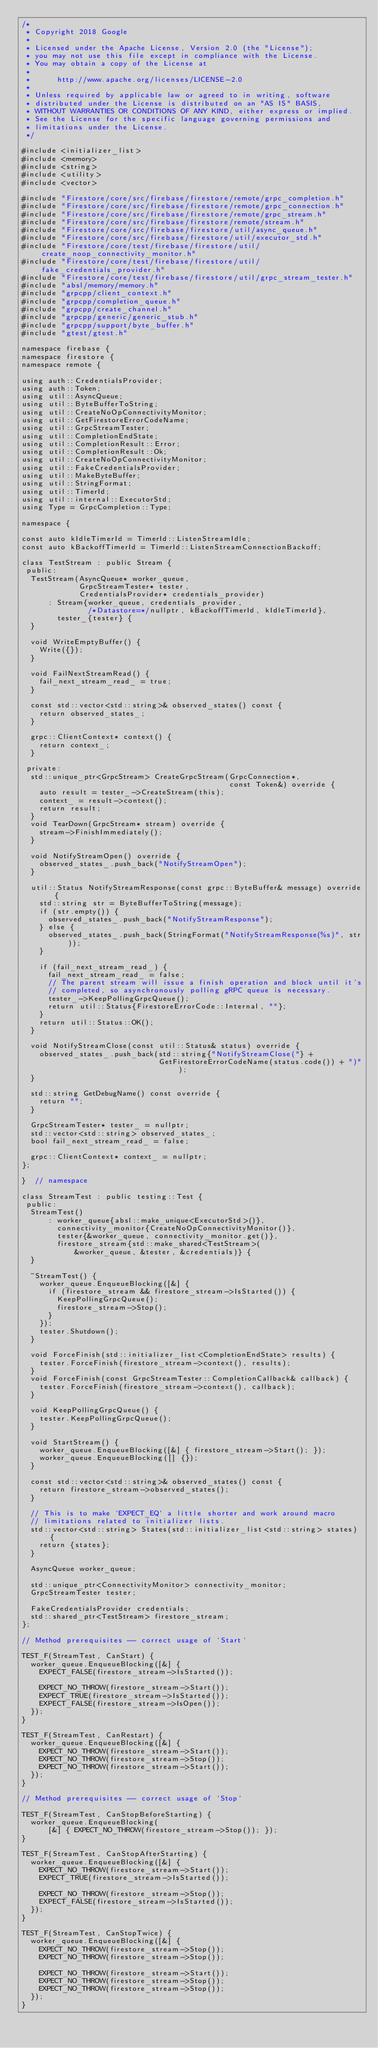<code> <loc_0><loc_0><loc_500><loc_500><_ObjectiveC_>/*
 * Copyright 2018 Google
 *
 * Licensed under the Apache License, Version 2.0 (the "License");
 * you may not use this file except in compliance with the License.
 * You may obtain a copy of the License at
 *
 *      http://www.apache.org/licenses/LICENSE-2.0
 *
 * Unless required by applicable law or agreed to in writing, software
 * distributed under the License is distributed on an "AS IS" BASIS,
 * WITHOUT WARRANTIES OR CONDITIONS OF ANY KIND, either express or implied.
 * See the License for the specific language governing permissions and
 * limitations under the License.
 */

#include <initializer_list>
#include <memory>
#include <string>
#include <utility>
#include <vector>

#include "Firestore/core/src/firebase/firestore/remote/grpc_completion.h"
#include "Firestore/core/src/firebase/firestore/remote/grpc_connection.h"
#include "Firestore/core/src/firebase/firestore/remote/grpc_stream.h"
#include "Firestore/core/src/firebase/firestore/remote/stream.h"
#include "Firestore/core/src/firebase/firestore/util/async_queue.h"
#include "Firestore/core/src/firebase/firestore/util/executor_std.h"
#include "Firestore/core/test/firebase/firestore/util/create_noop_connectivity_monitor.h"
#include "Firestore/core/test/firebase/firestore/util/fake_credentials_provider.h"
#include "Firestore/core/test/firebase/firestore/util/grpc_stream_tester.h"
#include "absl/memory/memory.h"
#include "grpcpp/client_context.h"
#include "grpcpp/completion_queue.h"
#include "grpcpp/create_channel.h"
#include "grpcpp/generic/generic_stub.h"
#include "grpcpp/support/byte_buffer.h"
#include "gtest/gtest.h"

namespace firebase {
namespace firestore {
namespace remote {

using auth::CredentialsProvider;
using auth::Token;
using util::AsyncQueue;
using util::ByteBufferToString;
using util::CreateNoOpConnectivityMonitor;
using util::GetFirestoreErrorCodeName;
using util::GrpcStreamTester;
using util::CompletionEndState;
using util::CompletionResult::Error;
using util::CompletionResult::Ok;
using util::CreateNoOpConnectivityMonitor;
using util::FakeCredentialsProvider;
using util::MakeByteBuffer;
using util::StringFormat;
using util::TimerId;
using util::internal::ExecutorStd;
using Type = GrpcCompletion::Type;

namespace {

const auto kIdleTimerId = TimerId::ListenStreamIdle;
const auto kBackoffTimerId = TimerId::ListenStreamConnectionBackoff;

class TestStream : public Stream {
 public:
  TestStream(AsyncQueue* worker_queue,
             GrpcStreamTester* tester,
             CredentialsProvider* credentials_provider)
      : Stream{worker_queue, credentials_provider,
               /*Datastore=*/nullptr, kBackoffTimerId, kIdleTimerId},
        tester_{tester} {
  }

  void WriteEmptyBuffer() {
    Write({});
  }

  void FailNextStreamRead() {
    fail_next_stream_read_ = true;
  }

  const std::vector<std::string>& observed_states() const {
    return observed_states_;
  }

  grpc::ClientContext* context() {
    return context_;
  }

 private:
  std::unique_ptr<GrpcStream> CreateGrpcStream(GrpcConnection*,
                                               const Token&) override {
    auto result = tester_->CreateStream(this);
    context_ = result->context();
    return result;
  }
  void TearDown(GrpcStream* stream) override {
    stream->FinishImmediately();
  }

  void NotifyStreamOpen() override {
    observed_states_.push_back("NotifyStreamOpen");
  }

  util::Status NotifyStreamResponse(const grpc::ByteBuffer& message) override {
    std::string str = ByteBufferToString(message);
    if (str.empty()) {
      observed_states_.push_back("NotifyStreamResponse");
    } else {
      observed_states_.push_back(StringFormat("NotifyStreamResponse(%s)", str));
    }

    if (fail_next_stream_read_) {
      fail_next_stream_read_ = false;
      // The parent stream will issue a finish operation and block until it's
      // completed, so asynchronously polling gRPC queue is necessary.
      tester_->KeepPollingGrpcQueue();
      return util::Status{FirestoreErrorCode::Internal, ""};
    }
    return util::Status::OK();
  }

  void NotifyStreamClose(const util::Status& status) override {
    observed_states_.push_back(std::string{"NotifyStreamClose("} +
                               GetFirestoreErrorCodeName(status.code()) + ")");
  }

  std::string GetDebugName() const override {
    return "";
  }

  GrpcStreamTester* tester_ = nullptr;
  std::vector<std::string> observed_states_;
  bool fail_next_stream_read_ = false;

  grpc::ClientContext* context_ = nullptr;
};

}  // namespace

class StreamTest : public testing::Test {
 public:
  StreamTest()
      : worker_queue{absl::make_unique<ExecutorStd>()},
        connectivity_monitor{CreateNoOpConnectivityMonitor()},
        tester{&worker_queue, connectivity_monitor.get()},
        firestore_stream{std::make_shared<TestStream>(
            &worker_queue, &tester, &credentials)} {
  }

  ~StreamTest() {
    worker_queue.EnqueueBlocking([&] {
      if (firestore_stream && firestore_stream->IsStarted()) {
        KeepPollingGrpcQueue();
        firestore_stream->Stop();
      }
    });
    tester.Shutdown();
  }

  void ForceFinish(std::initializer_list<CompletionEndState> results) {
    tester.ForceFinish(firestore_stream->context(), results);
  }
  void ForceFinish(const GrpcStreamTester::CompletionCallback& callback) {
    tester.ForceFinish(firestore_stream->context(), callback);
  }

  void KeepPollingGrpcQueue() {
    tester.KeepPollingGrpcQueue();
  }

  void StartStream() {
    worker_queue.EnqueueBlocking([&] { firestore_stream->Start(); });
    worker_queue.EnqueueBlocking([] {});
  }

  const std::vector<std::string>& observed_states() const {
    return firestore_stream->observed_states();
  }

  // This is to make `EXPECT_EQ` a little shorter and work around macro
  // limitations related to initializer lists.
  std::vector<std::string> States(std::initializer_list<std::string> states) {
    return {states};
  }

  AsyncQueue worker_queue;

  std::unique_ptr<ConnectivityMonitor> connectivity_monitor;
  GrpcStreamTester tester;

  FakeCredentialsProvider credentials;
  std::shared_ptr<TestStream> firestore_stream;
};

// Method prerequisites -- correct usage of `Start`

TEST_F(StreamTest, CanStart) {
  worker_queue.EnqueueBlocking([&] {
    EXPECT_FALSE(firestore_stream->IsStarted());

    EXPECT_NO_THROW(firestore_stream->Start());
    EXPECT_TRUE(firestore_stream->IsStarted());
    EXPECT_FALSE(firestore_stream->IsOpen());
  });
}

TEST_F(StreamTest, CanRestart) {
  worker_queue.EnqueueBlocking([&] {
    EXPECT_NO_THROW(firestore_stream->Start());
    EXPECT_NO_THROW(firestore_stream->Stop());
    EXPECT_NO_THROW(firestore_stream->Start());
  });
}

// Method prerequisites -- correct usage of `Stop`

TEST_F(StreamTest, CanStopBeforeStarting) {
  worker_queue.EnqueueBlocking(
      [&] { EXPECT_NO_THROW(firestore_stream->Stop()); });
}

TEST_F(StreamTest, CanStopAfterStarting) {
  worker_queue.EnqueueBlocking([&] {
    EXPECT_NO_THROW(firestore_stream->Start());
    EXPECT_TRUE(firestore_stream->IsStarted());

    EXPECT_NO_THROW(firestore_stream->Stop());
    EXPECT_FALSE(firestore_stream->IsStarted());
  });
}

TEST_F(StreamTest, CanStopTwice) {
  worker_queue.EnqueueBlocking([&] {
    EXPECT_NO_THROW(firestore_stream->Stop());
    EXPECT_NO_THROW(firestore_stream->Stop());

    EXPECT_NO_THROW(firestore_stream->Start());
    EXPECT_NO_THROW(firestore_stream->Stop());
    EXPECT_NO_THROW(firestore_stream->Stop());
  });
}
</code> 